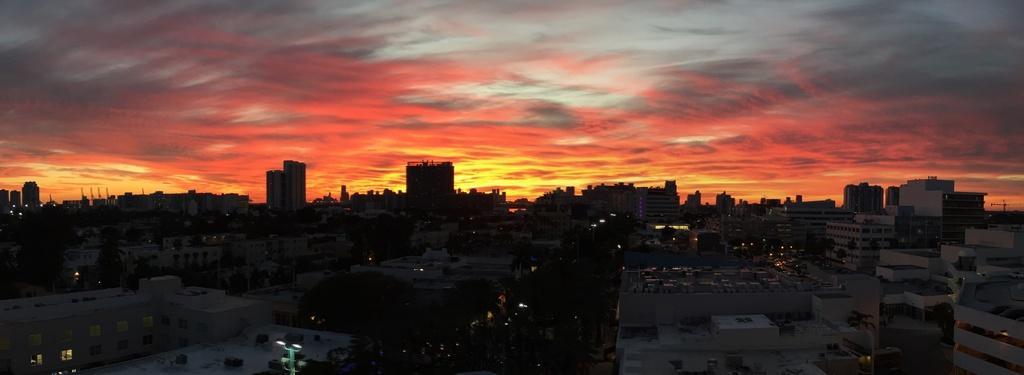In one or two sentences, can you explain what this image depicts? In this picture we can see buildings, trees, poles, and lights. In the background there is sky. 